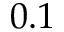Convert formula to latex. <formula><loc_0><loc_0><loc_500><loc_500>0 . 1</formula> 